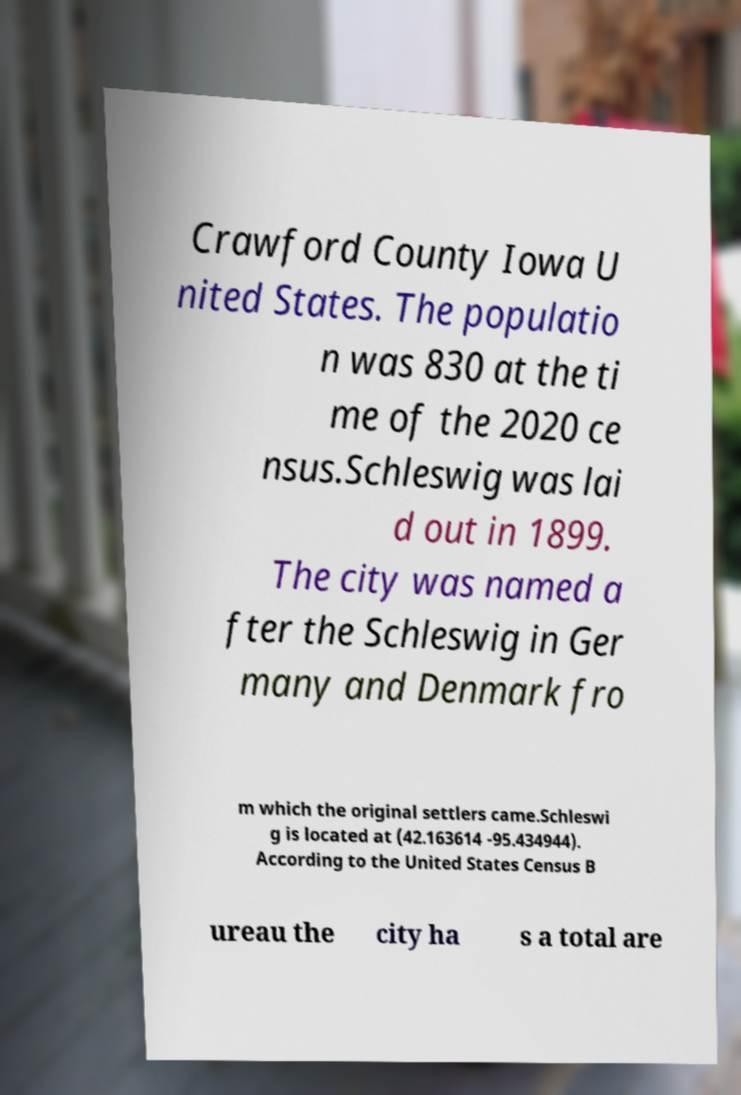For documentation purposes, I need the text within this image transcribed. Could you provide that? Crawford County Iowa U nited States. The populatio n was 830 at the ti me of the 2020 ce nsus.Schleswig was lai d out in 1899. The city was named a fter the Schleswig in Ger many and Denmark fro m which the original settlers came.Schleswi g is located at (42.163614 -95.434944). According to the United States Census B ureau the city ha s a total are 